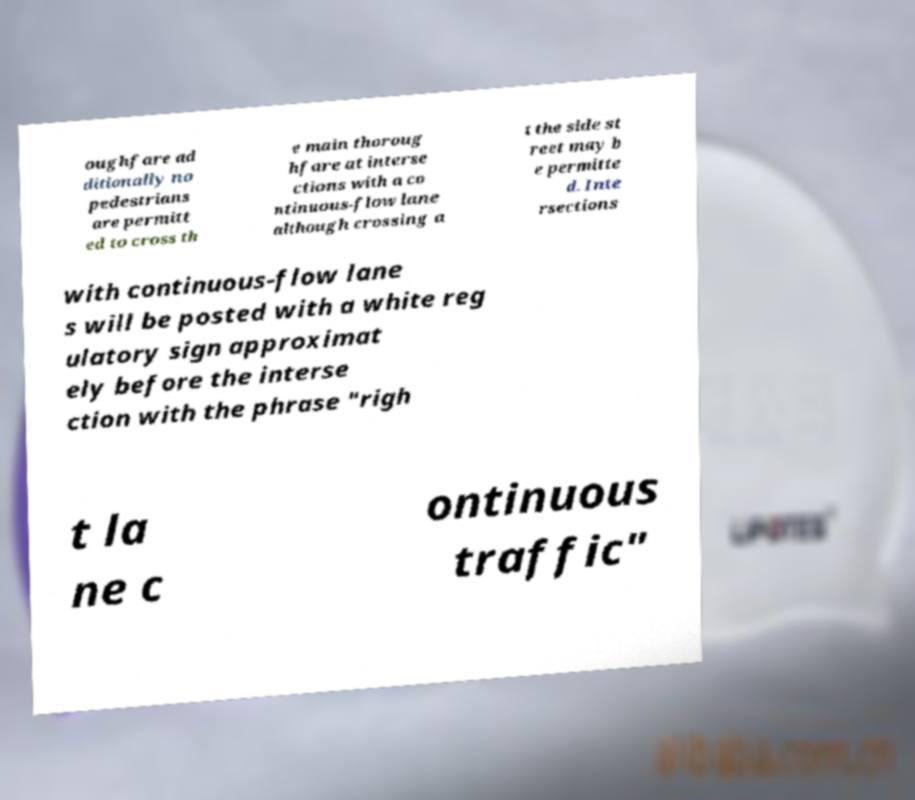Can you accurately transcribe the text from the provided image for me? oughfare ad ditionally no pedestrians are permitt ed to cross th e main thoroug hfare at interse ctions with a co ntinuous-flow lane although crossing a t the side st reet may b e permitte d. Inte rsections with continuous-flow lane s will be posted with a white reg ulatory sign approximat ely before the interse ction with the phrase "righ t la ne c ontinuous traffic" 